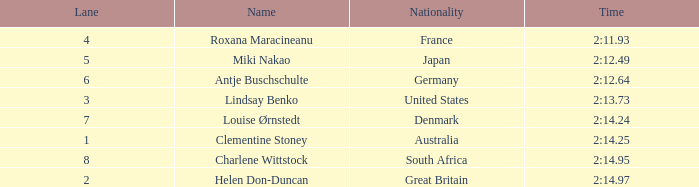What shows for nationality when there is a rank larger than 6, and a Time of 2:14.95? South Africa. 